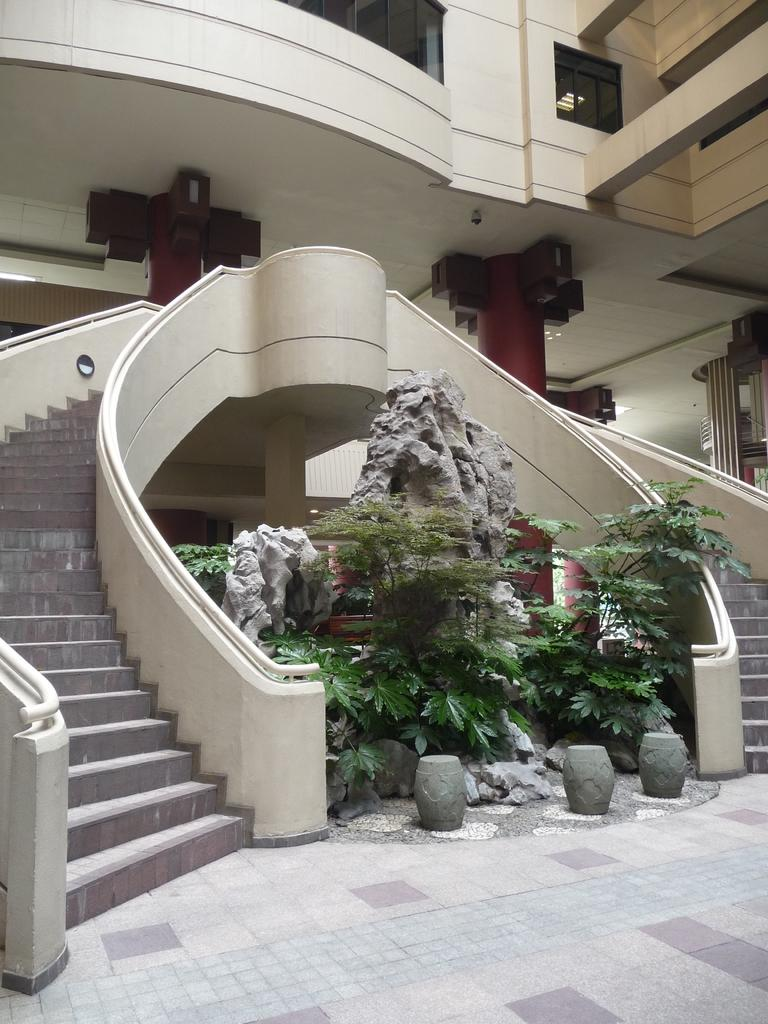What type of structure is visible in the image? There is a building in the image. What is the color of the building? The building is cream-colored. What can be seen in front of the building? There are rocks and plants in front of the building. How can someone access the building from the front? There are stairs to the side of the plants that provide access to the building. How many thumbs are visible in the image? There are no thumbs visible in the image. What type of balls are being used for destruction in the image? There are no balls or destruction present in the image. 